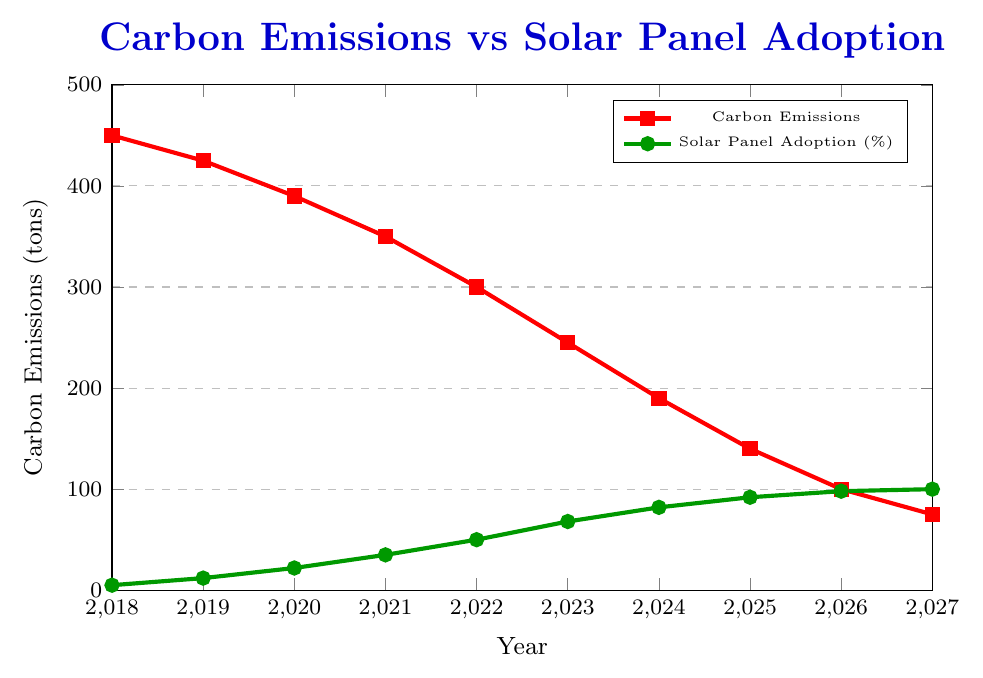What is the trend in carbon emissions from 2018 to 2027? The trend in carbon emissions is shown by the red line in the figure. It starts at 450 tons in 2018 and consistently decreases every year until it reaches 75 tons in 2027. This shows a clear downward trend.
Answer: Downward trend What is the relationship between solar panel adoption and carbon emissions? The figure shows two lines: a green line for solar panel adoption and a red line for carbon emissions. As the green line increases (solar panel adoption rises), the red line decreases (carbon emissions fall). This inverse relationship suggests that as more households adopt solar panels, carbon emissions reduce.
Answer: Inverse relationship By how many tons did carbon emissions reduce from 2018 to 2020? In 2018, carbon emissions were 450 tons. By 2020, they had decreased to 390 tons. The difference is calculated as 450 - 390 = 60 tons.
Answer: 60 tons Between which two consecutive years was the increase in solar panel adoption the greatest? Examining the green line, we see the largest jump in percentage points between 2023 and 2024, where it goes from 68% to 82%. The difference is calculated as 82 - 68 = 14 percentage points.
Answer: 2023-2024 What is the average annual reduction in carbon emissions over the given period? To find the average annual reduction, take the difference between the carbon emissions in 2018 and 2027, then divide by the number of years. The calculation is (450 - 75) / (2027 - 2018) = 375 / 9 = 41.67 tons per year.
Answer: 41.67 tons per year In which year did solar panel adoption reach 50%? Referring to the green line, solar panel adoption reached 50% in the year 2022.
Answer: 2022 How does the reduction in carbon emissions between 2020 and 2021 compare with the reduction between 2024 and 2025? Between 2020 and 2021, carbon emissions reduced from 390 tons to 350 tons, a difference of 40 tons. Between 2024 and 2025, they reduced from 190 tons to 140 tons, a difference of 50 tons. Comparing the two, the reduction from 2024 to 2025 was greater.
Answer: 2024-2025 was greater What color represents carbon emissions in the figure? The red line represents carbon emissions in the figure.
Answer: Red What is the total reduction in carbon emissions from 2018 to 2027? Carbon emissions decreased from 450 tons in 2018 to 75 tons in 2027. The total reduction is calculated as 450 - 75 = 375 tons.
Answer: 375 tons 